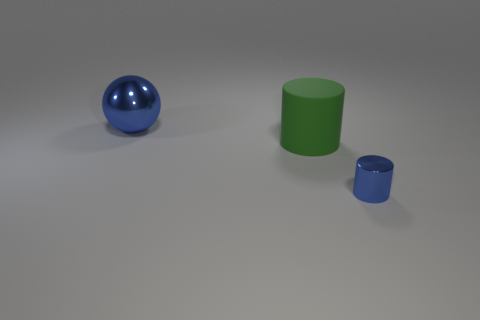Add 2 large matte cylinders. How many objects exist? 5 Subtract all green cylinders. How many cylinders are left? 1 Subtract 1 spheres. How many spheres are left? 0 Subtract all spheres. How many objects are left? 2 Subtract all red cylinders. Subtract all cyan spheres. How many cylinders are left? 2 Subtract all red blocks. How many purple cylinders are left? 0 Subtract all tiny blue things. Subtract all green matte things. How many objects are left? 1 Add 1 blue spheres. How many blue spheres are left? 2 Add 1 small blue metallic objects. How many small blue metallic objects exist? 2 Subtract 1 blue cylinders. How many objects are left? 2 